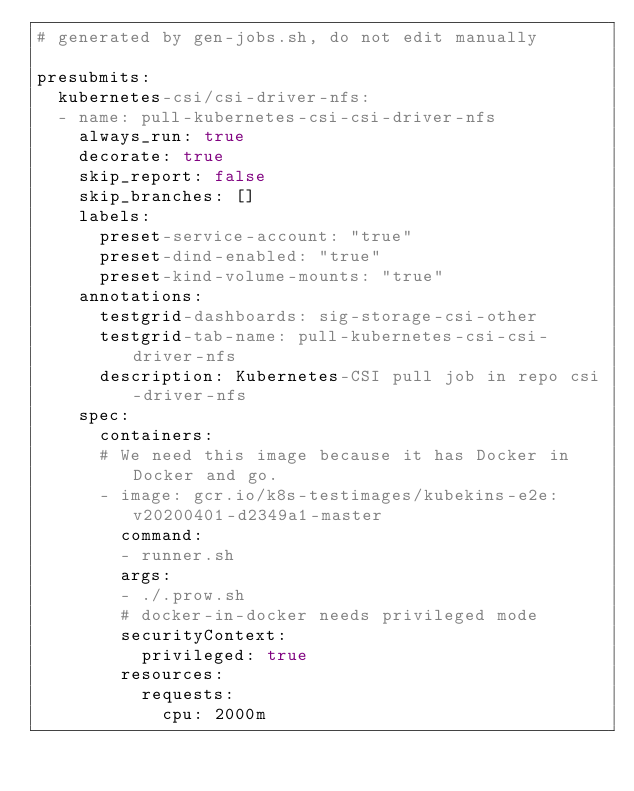<code> <loc_0><loc_0><loc_500><loc_500><_YAML_># generated by gen-jobs.sh, do not edit manually

presubmits:
  kubernetes-csi/csi-driver-nfs:
  - name: pull-kubernetes-csi-csi-driver-nfs
    always_run: true
    decorate: true
    skip_report: false
    skip_branches: []
    labels:
      preset-service-account: "true"
      preset-dind-enabled: "true"
      preset-kind-volume-mounts: "true"
    annotations:
      testgrid-dashboards: sig-storage-csi-other
      testgrid-tab-name: pull-kubernetes-csi-csi-driver-nfs
      description: Kubernetes-CSI pull job in repo csi-driver-nfs
    spec:
      containers:
      # We need this image because it has Docker in Docker and go.
      - image: gcr.io/k8s-testimages/kubekins-e2e:v20200401-d2349a1-master
        command:
        - runner.sh
        args:
        - ./.prow.sh
        # docker-in-docker needs privileged mode
        securityContext:
          privileged: true
        resources:
          requests:
            cpu: 2000m
</code> 